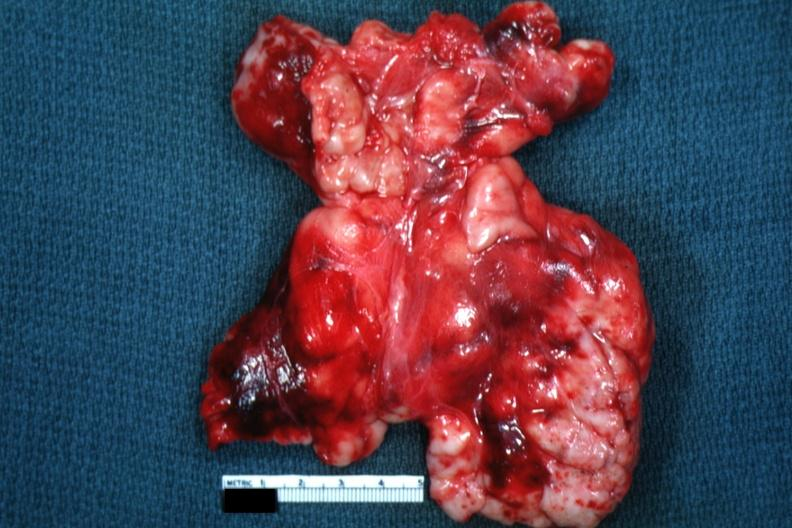what is present?
Answer the question using a single word or phrase. Thymus 